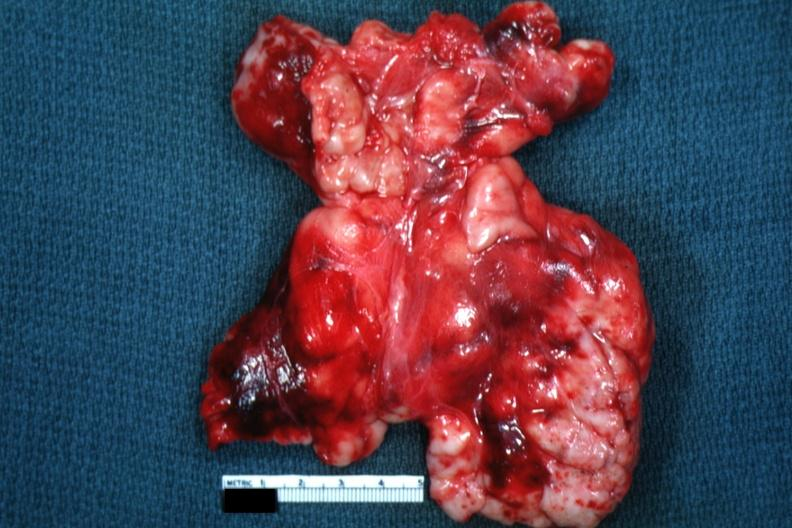what is present?
Answer the question using a single word or phrase. Thymus 